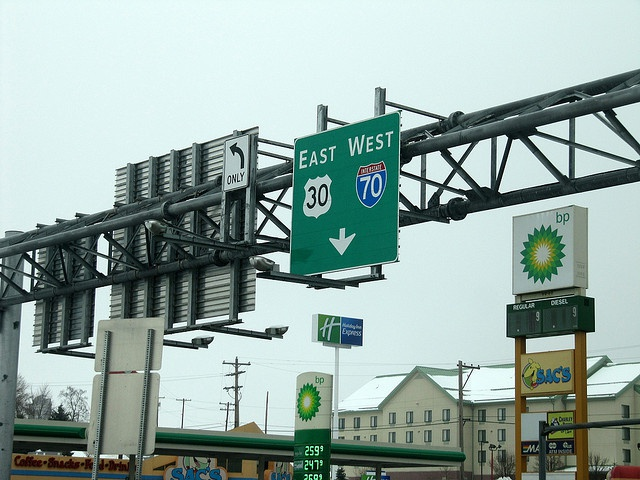Describe the objects in this image and their specific colors. I can see various objects in this image with different colors. 